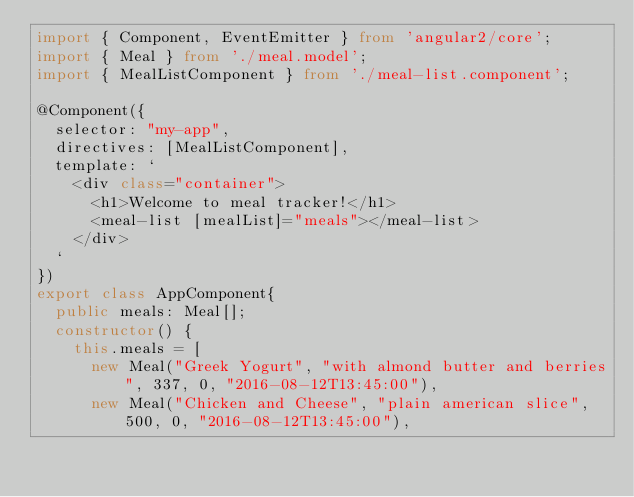<code> <loc_0><loc_0><loc_500><loc_500><_TypeScript_>import { Component, EventEmitter } from 'angular2/core';
import { Meal } from './meal.model';
import { MealListComponent } from './meal-list.component';

@Component({
  selector: "my-app",
  directives: [MealListComponent],
  template: `
    <div class="container">
      <h1>Welcome to meal tracker!</h1>
      <meal-list [mealList]="meals"></meal-list>
    </div>
  `
})
export class AppComponent{
  public meals: Meal[];
  constructor() {
    this.meals = [
      new Meal("Greek Yogurt", "with almond butter and berries", 337, 0, "2016-08-12T13:45:00"),
      new Meal("Chicken and Cheese", "plain american slice", 500, 0, "2016-08-12T13:45:00"),</code> 